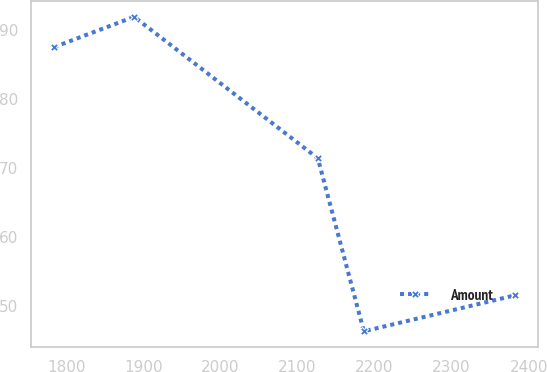<chart> <loc_0><loc_0><loc_500><loc_500><line_chart><ecel><fcel>Amount<nl><fcel>1784.48<fcel>87.55<nl><fcel>1888.21<fcel>91.94<nl><fcel>2126.44<fcel>71.44<nl><fcel>2186.14<fcel>46.36<nl><fcel>2381.47<fcel>51.56<nl></chart> 